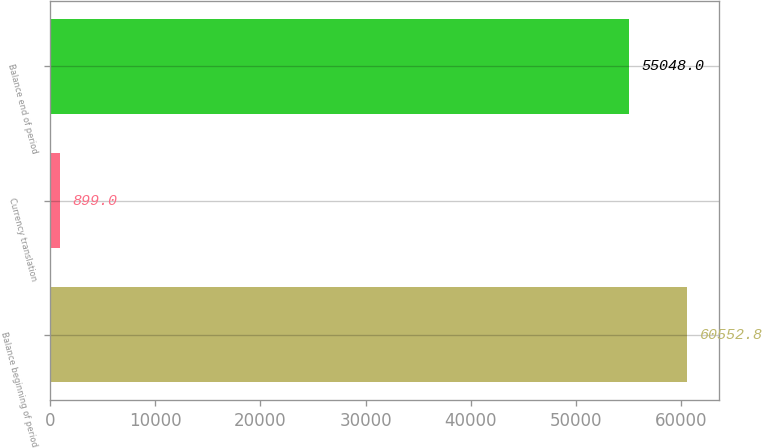<chart> <loc_0><loc_0><loc_500><loc_500><bar_chart><fcel>Balance beginning of period<fcel>Currency translation<fcel>Balance end of period<nl><fcel>60552.8<fcel>899<fcel>55048<nl></chart> 